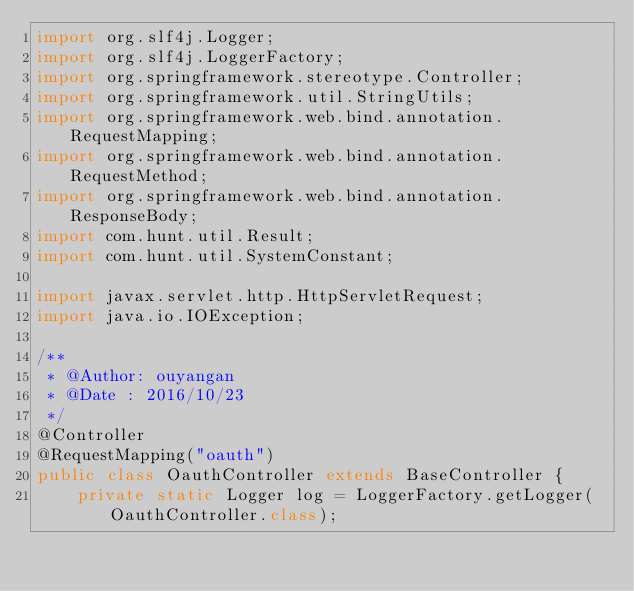Convert code to text. <code><loc_0><loc_0><loc_500><loc_500><_Java_>import org.slf4j.Logger;
import org.slf4j.LoggerFactory;
import org.springframework.stereotype.Controller;
import org.springframework.util.StringUtils;
import org.springframework.web.bind.annotation.RequestMapping;
import org.springframework.web.bind.annotation.RequestMethod;
import org.springframework.web.bind.annotation.ResponseBody;
import com.hunt.util.Result;
import com.hunt.util.SystemConstant;

import javax.servlet.http.HttpServletRequest;
import java.io.IOException;

/**
 * @Author: ouyangan
 * @Date : 2016/10/23
 */
@Controller
@RequestMapping("oauth")
public class OauthController extends BaseController {
    private static Logger log = LoggerFactory.getLogger(OauthController.class);
</code> 